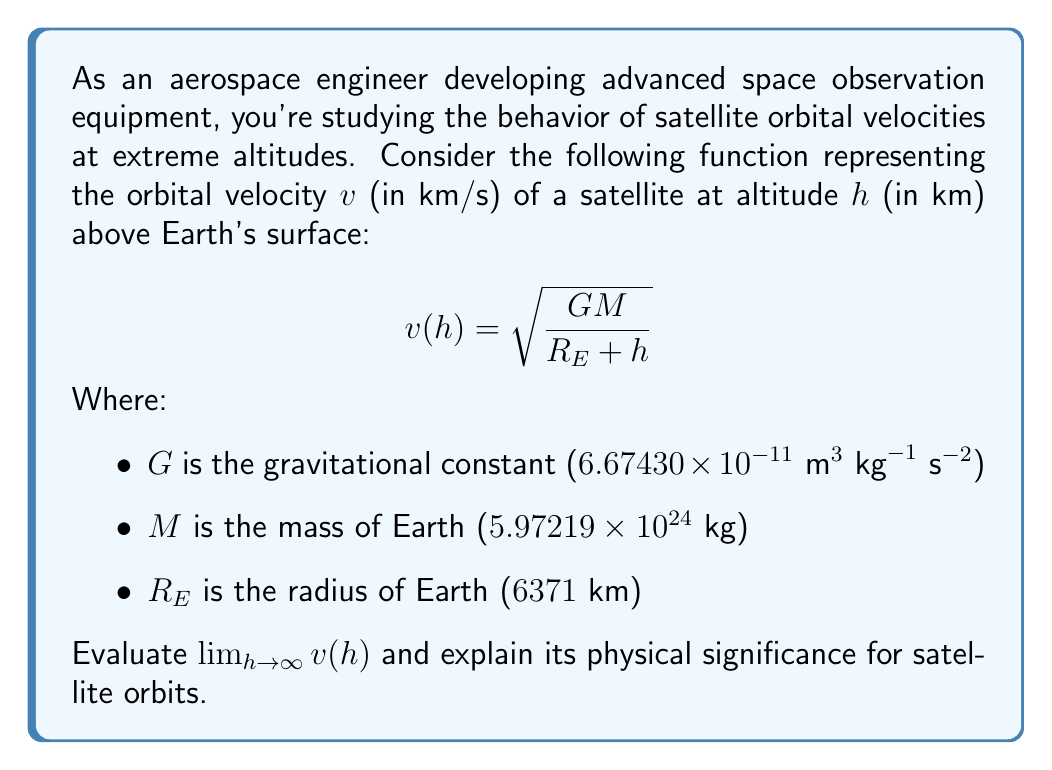Show me your answer to this math problem. Let's approach this step-by-step:

1) First, we need to understand what happens to the function as $h$ approaches infinity:

   $$\lim_{h \to \infty} v(h) = \lim_{h \to \infty} \sqrt{\frac{GM}{R_E + h}}$$

2) As $h$ increases, the denominator $(R_E + h)$ grows much larger than $R_E$. For very large $h$, we can approximate:

   $$\lim_{h \to \infty} \sqrt{\frac{GM}{R_E + h}} \approx \lim_{h \to \infty} \sqrt{\frac{GM}{h}}$$

3) Now, we can rewrite this as:

   $$\lim_{h \to \infty} \sqrt{\frac{GM}{h}} = \sqrt{GM} \cdot \lim_{h \to \infty} \frac{1}{\sqrt{h}}$$

4) We know that as $h$ approaches infinity, $\frac{1}{\sqrt{h}}$ approaches zero:

   $$\lim_{h \to \infty} \frac{1}{\sqrt{h}} = 0$$

5) Therefore:

   $$\lim_{h \to \infty} v(h) = \sqrt{GM} \cdot 0 = 0$$

Physical significance: As a satellite's altitude approaches infinity, its orbital velocity approaches zero. This makes sense because at infinite distance from Earth, the gravitational influence becomes negligible, and the satellite would effectively be at rest relative to Earth. This insight is crucial for designing equipment for deep space observation, where satellites or probes operate at extremely high altitudes.
Answer: $0 \text{ km/s}$ 